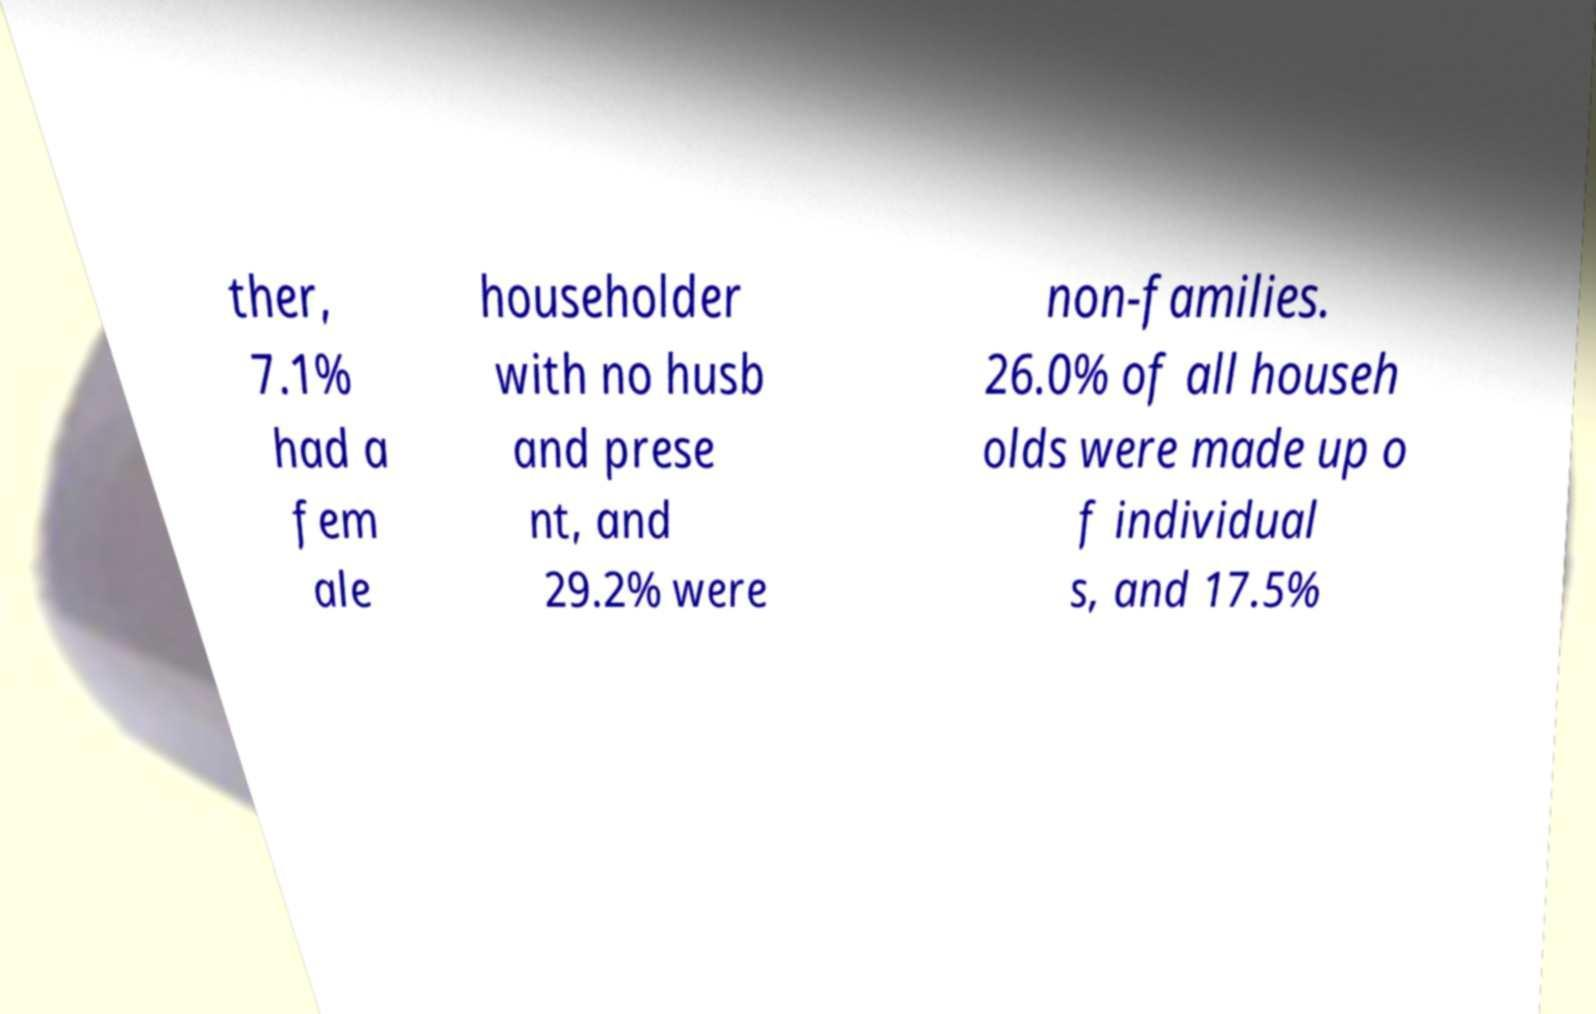Can you accurately transcribe the text from the provided image for me? ther, 7.1% had a fem ale householder with no husb and prese nt, and 29.2% were non-families. 26.0% of all househ olds were made up o f individual s, and 17.5% 